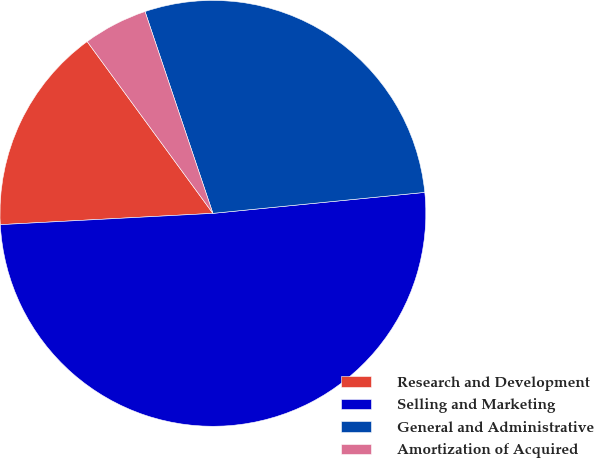Convert chart. <chart><loc_0><loc_0><loc_500><loc_500><pie_chart><fcel>Research and Development<fcel>Selling and Marketing<fcel>General and Administrative<fcel>Amortization of Acquired<nl><fcel>15.79%<fcel>50.72%<fcel>28.59%<fcel>4.89%<nl></chart> 